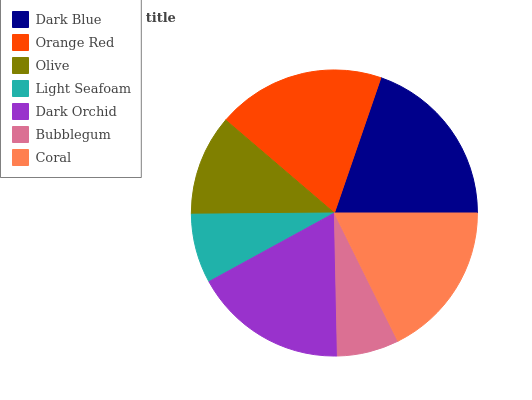Is Bubblegum the minimum?
Answer yes or no. Yes. Is Dark Blue the maximum?
Answer yes or no. Yes. Is Orange Red the minimum?
Answer yes or no. No. Is Orange Red the maximum?
Answer yes or no. No. Is Dark Blue greater than Orange Red?
Answer yes or no. Yes. Is Orange Red less than Dark Blue?
Answer yes or no. Yes. Is Orange Red greater than Dark Blue?
Answer yes or no. No. Is Dark Blue less than Orange Red?
Answer yes or no. No. Is Dark Orchid the high median?
Answer yes or no. Yes. Is Dark Orchid the low median?
Answer yes or no. Yes. Is Light Seafoam the high median?
Answer yes or no. No. Is Dark Blue the low median?
Answer yes or no. No. 